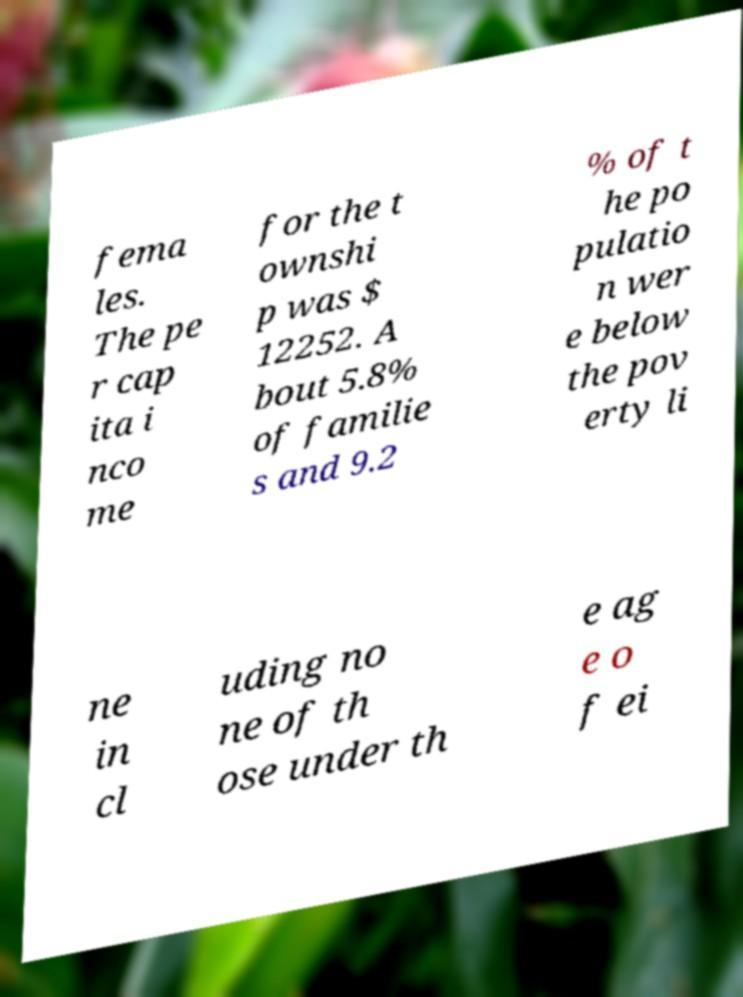Can you accurately transcribe the text from the provided image for me? fema les. The pe r cap ita i nco me for the t ownshi p was $ 12252. A bout 5.8% of familie s and 9.2 % of t he po pulatio n wer e below the pov erty li ne in cl uding no ne of th ose under th e ag e o f ei 